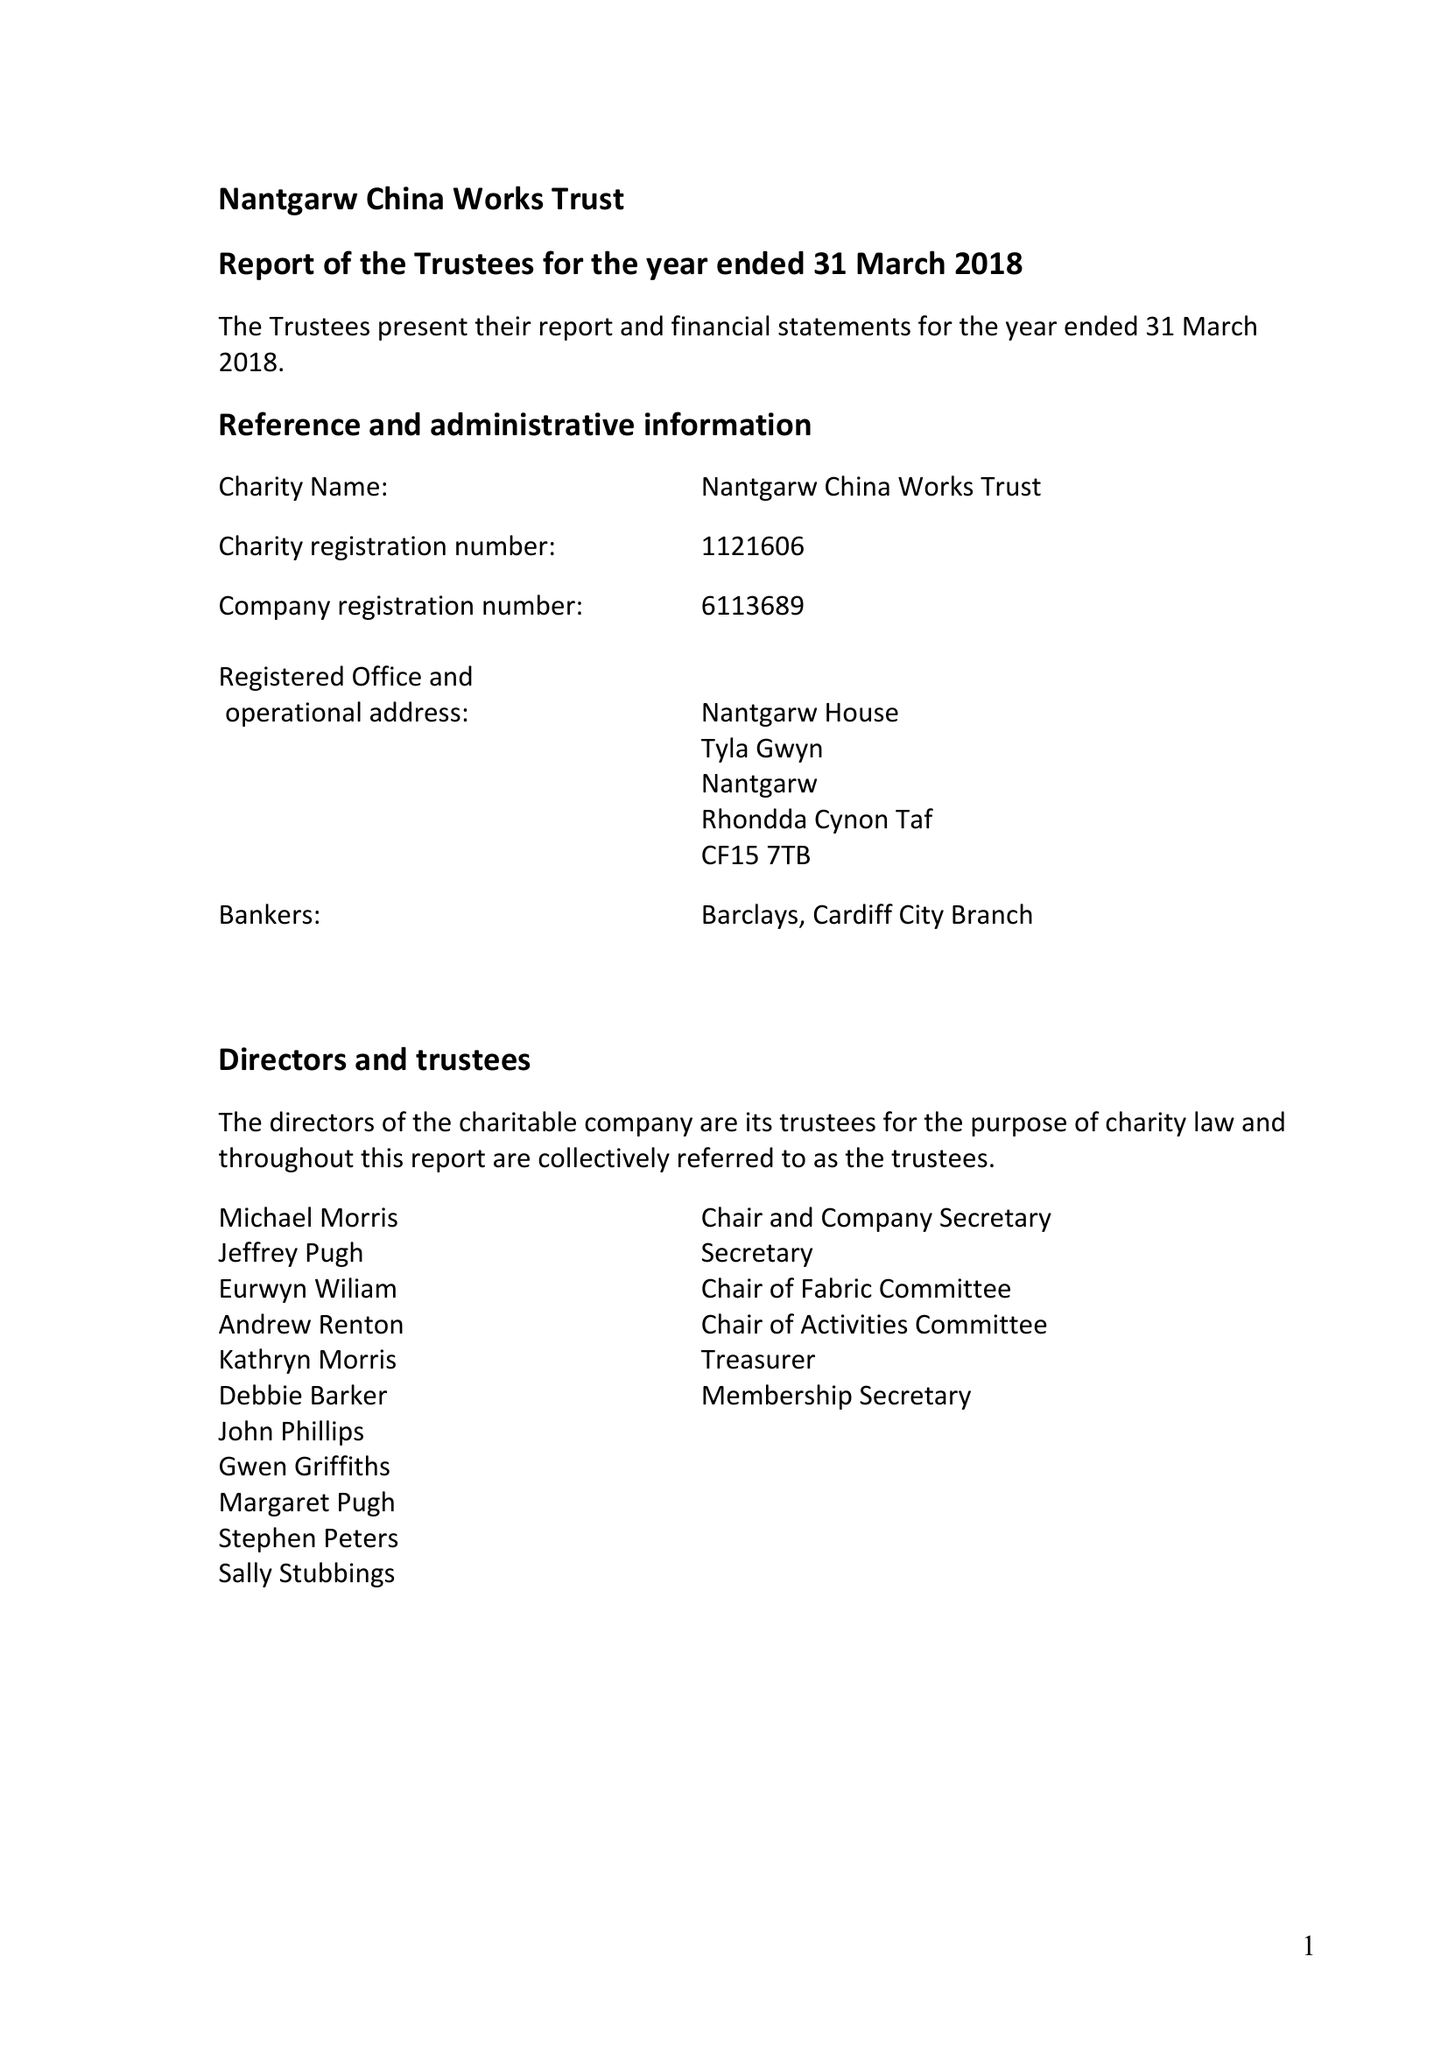What is the value for the spending_annually_in_british_pounds?
Answer the question using a single word or phrase. 32850.00 